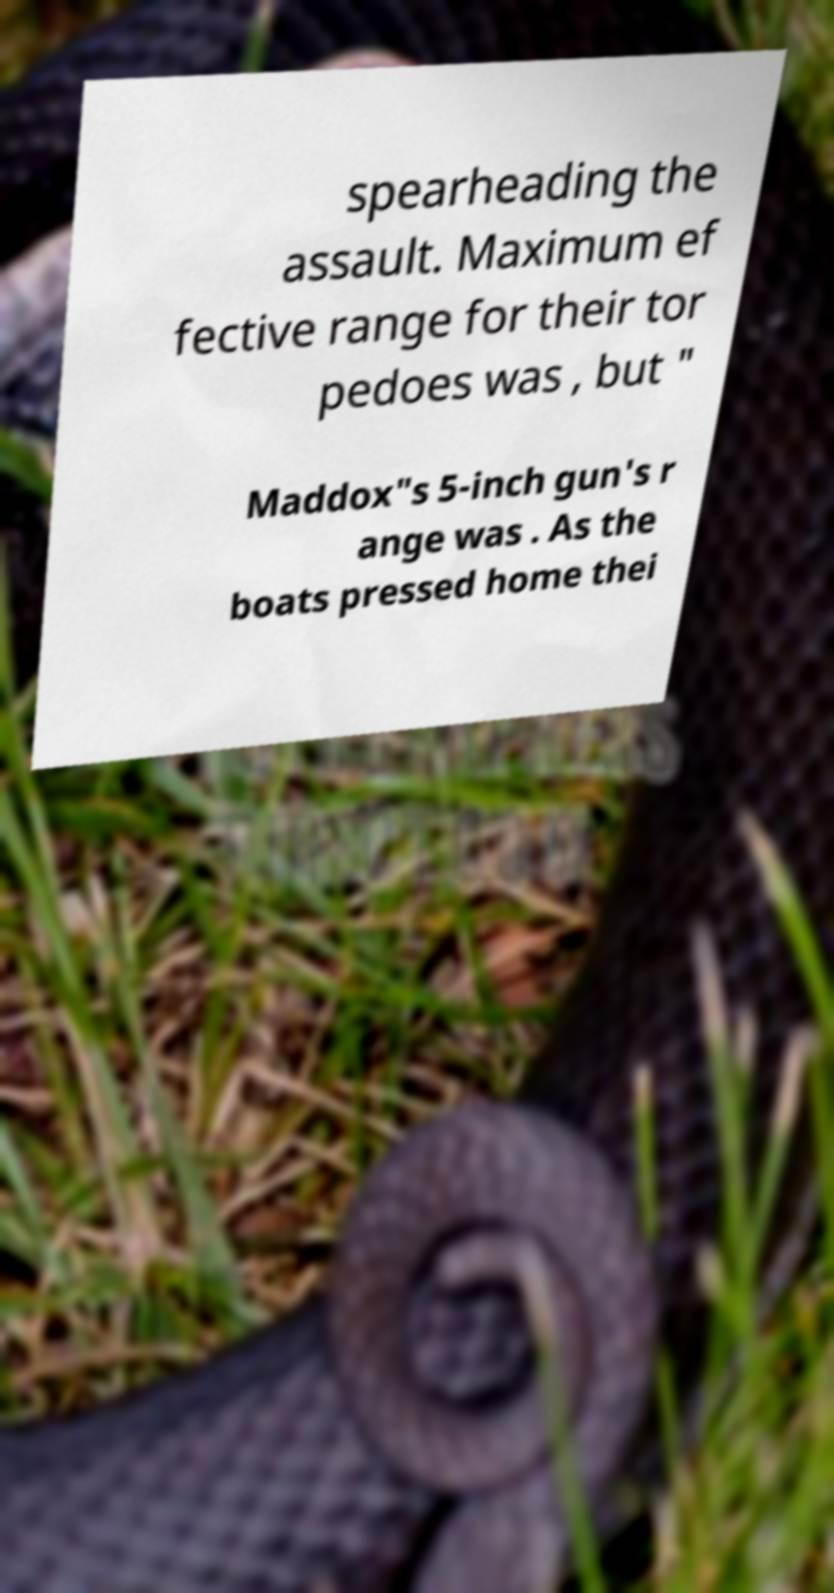What messages or text are displayed in this image? I need them in a readable, typed format. spearheading the assault. Maximum ef fective range for their tor pedoes was , but " Maddox"s 5-inch gun's r ange was . As the boats pressed home thei 